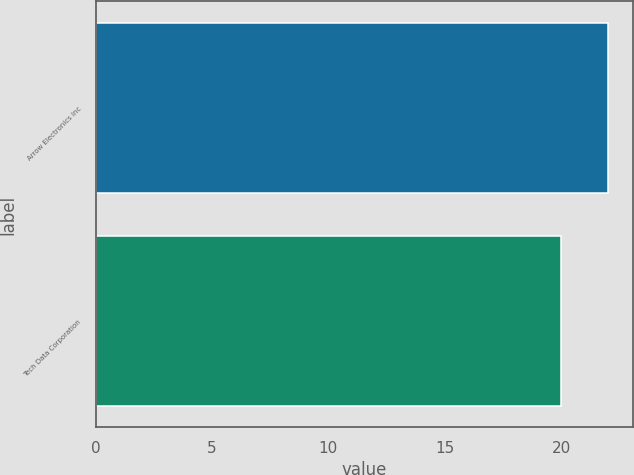<chart> <loc_0><loc_0><loc_500><loc_500><bar_chart><fcel>Arrow Electronics Inc<fcel>Tech Data Corporation<nl><fcel>22<fcel>20<nl></chart> 